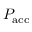Convert formula to latex. <formula><loc_0><loc_0><loc_500><loc_500>P _ { a c c }</formula> 